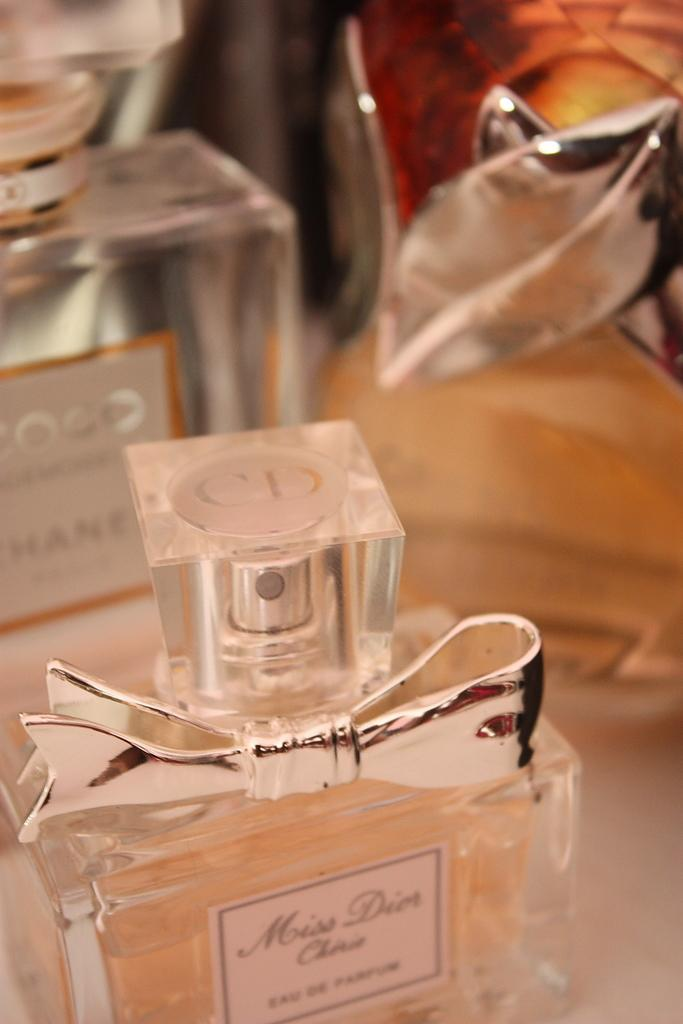<image>
Give a short and clear explanation of the subsequent image. Several fragrance bottles sit on a table, one being a Coco scent. 